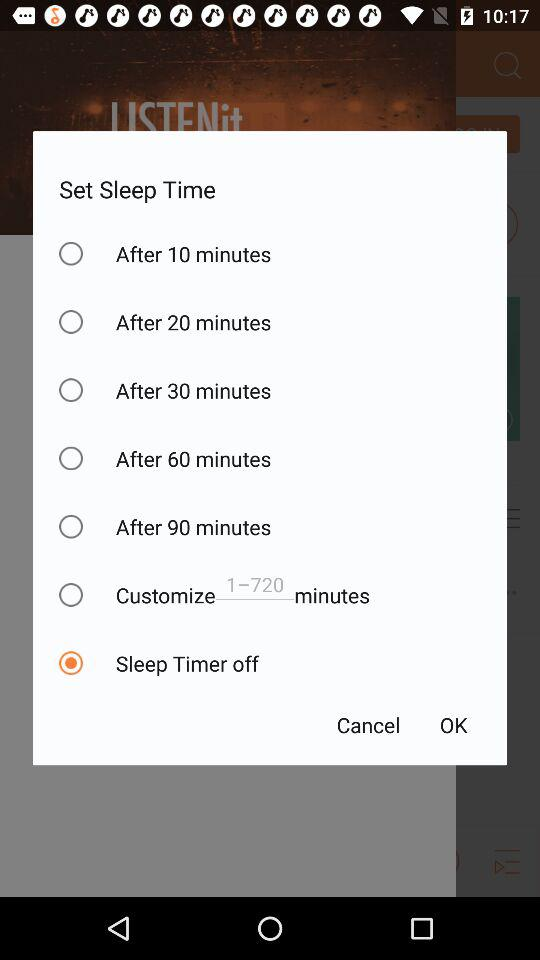For which days is the sleep time set?
When the provided information is insufficient, respond with <no answer>. <no answer> 